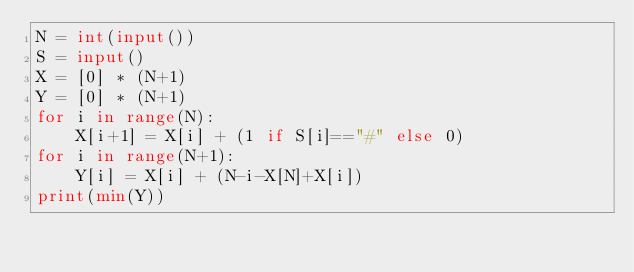<code> <loc_0><loc_0><loc_500><loc_500><_Python_>N = int(input())
S = input()
X = [0] * (N+1)
Y = [0] * (N+1)
for i in range(N):
    X[i+1] = X[i] + (1 if S[i]=="#" else 0)
for i in range(N+1):
    Y[i] = X[i] + (N-i-X[N]+X[i])
print(min(Y))</code> 